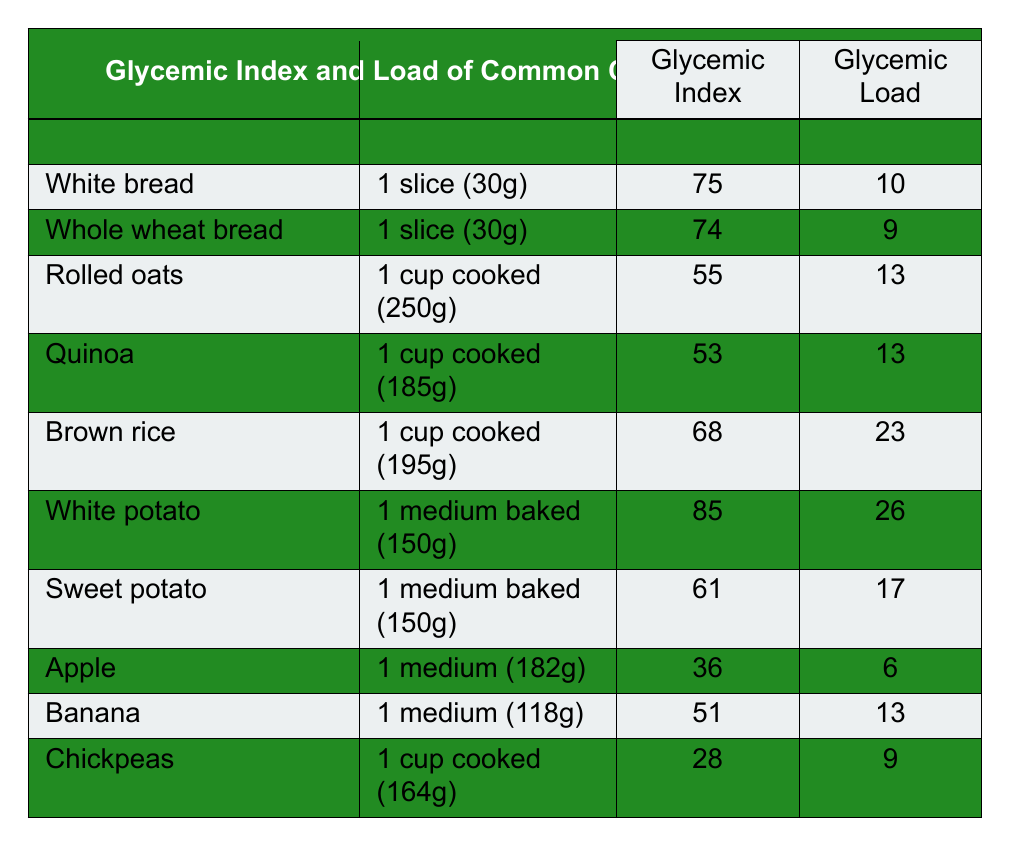What is the glycemic index of whole wheat bread? According to the table, whole wheat bread has a glycemic index of 74.
Answer: 74 Which food item has the highest glycemic load? The table shows white potato with a glycemic load of 26, which is the highest among all listed food items.
Answer: 26 Is the glycemic index of brown rice higher than that of quinoa? The glycemic index of brown rice is 68, while quinoa's is 53. Since 68 is greater than 53, the answer is yes.
Answer: Yes What is the serving size of rolled oats? The serving size for rolled oats is listed as 1 cup cooked (250g) in the table.
Answer: 1 cup cooked (250g) Calculate the average glycemic index of the foods listed. To find the average glycemic index, we sum all the glycemic indices: 75 + 74 + 55 + 53 + 68 + 85 + 61 + 36 + 51 + 28 =  714. There are 10 food items, so the average is 714/10 = 71.4.
Answer: 71.4 Which food item has the lowest glycemic load? The table indicates that the apple has the lowest glycemic load of 6 compared to the others.
Answer: 6 If someone were to eat two servings of sweet potatoes, what would the total glycemic load be? Each serving of sweet potato has a glycemic load of 17. Thus, for two servings, the total glycemic load would be 17 + 17 = 34.
Answer: 34 Are chickpeas healthier in terms of glycemic index compared to white bread? Chickpeas have a glycemic index of 28, while white bread has a glycemic index of 75, thus chickpeas are healthier as they have a lower glycemic index.
Answer: Yes What is the glycemic load difference between white potato and brown rice? White potato has a glycemic load of 26 and brown rice has a glycemic load of 23. The difference is 26 - 23 = 3.
Answer: 3 If you combine 1 serving of quinoa and 1 serving of chickpeas, what would their total glycemic load be? Quinoa has a glycemic load of 13 and chickpeas have a glycemic load of 9. Together, their total glycemic load is 13 + 9 = 22.
Answer: 22 